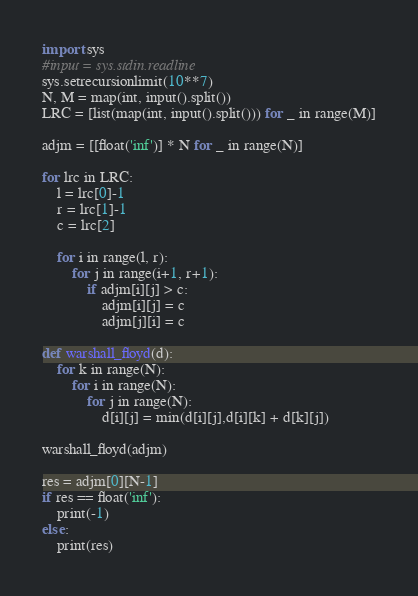<code> <loc_0><loc_0><loc_500><loc_500><_Python_>import sys
#input = sys.stdin.readline
sys.setrecursionlimit(10**7)
N, M = map(int, input().split())
LRC = [list(map(int, input().split())) for _ in range(M)]

adjm = [[float('inf')] * N for _ in range(N)]

for lrc in LRC:
    l = lrc[0]-1
    r = lrc[1]-1
    c = lrc[2]

    for i in range(l, r):
        for j in range(i+1, r+1):
            if adjm[i][j] > c:
                adjm[i][j] = c
                adjm[j][i] = c

def warshall_floyd(d):
    for k in range(N):
        for i in range(N):
            for j in range(N):
                d[i][j] = min(d[i][j],d[i][k] + d[k][j])

warshall_floyd(adjm)

res = adjm[0][N-1]
if res == float('inf'):
    print(-1)
else:
    print(res)</code> 